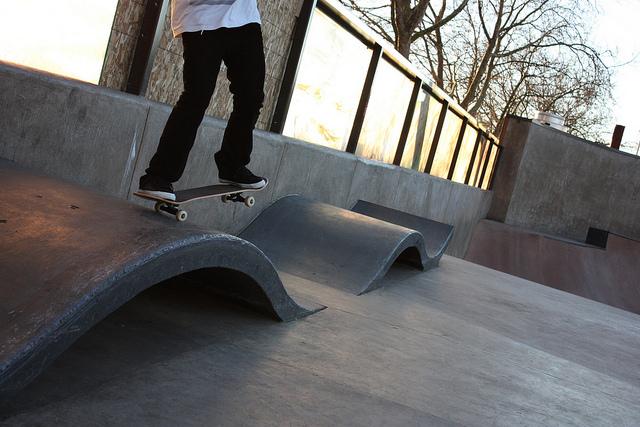Is the person skateboarding on a flat surface?
Concise answer only. No. Is this a park?
Be succinct. Yes. Is there someone on the skateboard?
Keep it brief. Yes. 